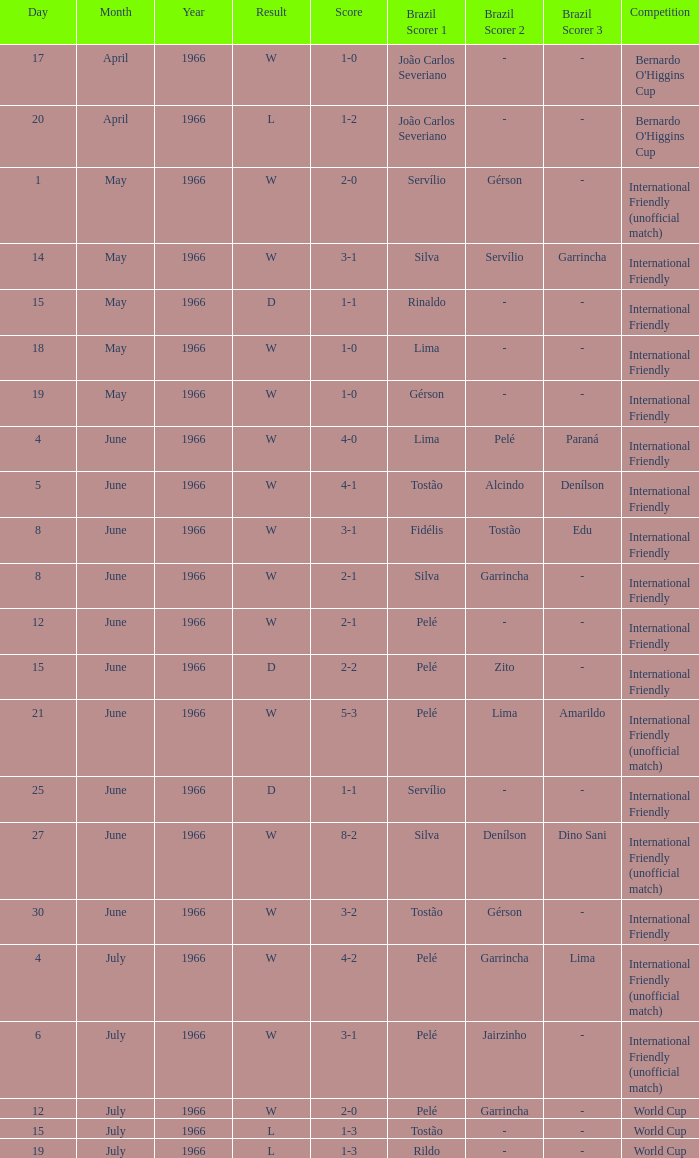What is the result of the International Friendly competition on May 15, 1966? D. 